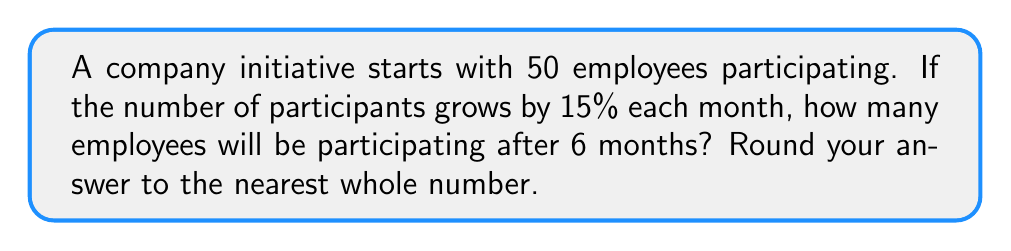Could you help me with this problem? Let's approach this step-by-step:

1) The initial number of participants is 50.

2) The growth rate is 15% per month, which as a decimal is 0.15.

3) We need to calculate this growth over 6 months.

4) The formula for exponential growth is:

   $$A = P(1 + r)^t$$

   Where:
   $A$ = Final amount
   $P$ = Initial principal balance
   $r$ = Growth rate (as a decimal)
   $t$ = Number of time periods

5) Plugging in our values:

   $$A = 50(1 + 0.15)^6$$

6) Let's calculate:

   $$A = 50(1.15)^6$$
   $$A = 50(2.3131)$$
   $$A = 115.655$$

7) Rounding to the nearest whole number:

   $$A ≈ 116$$

Therefore, after 6 months, approximately 116 employees will be participating in the initiative.
Answer: 116 employees 